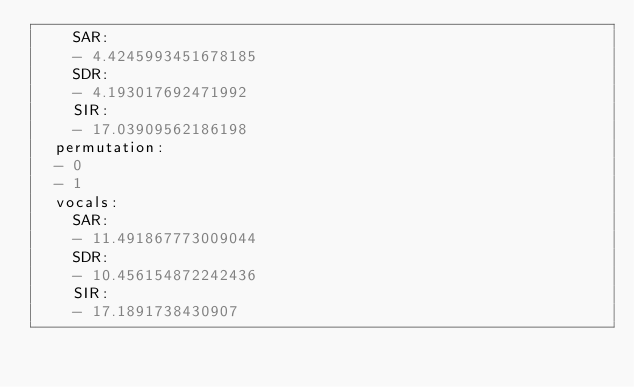<code> <loc_0><loc_0><loc_500><loc_500><_YAML_>    SAR:
    - 4.4245993451678185
    SDR:
    - 4.193017692471992
    SIR:
    - 17.03909562186198
  permutation:
  - 0
  - 1
  vocals:
    SAR:
    - 11.491867773009044
    SDR:
    - 10.456154872242436
    SIR:
    - 17.1891738430907
</code> 